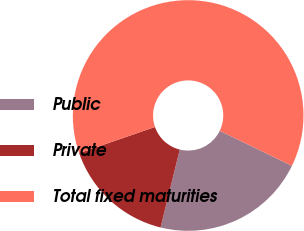<chart> <loc_0><loc_0><loc_500><loc_500><pie_chart><fcel>Public<fcel>Private<fcel>Total fixed maturities<nl><fcel>21.66%<fcel>15.86%<fcel>62.49%<nl></chart> 